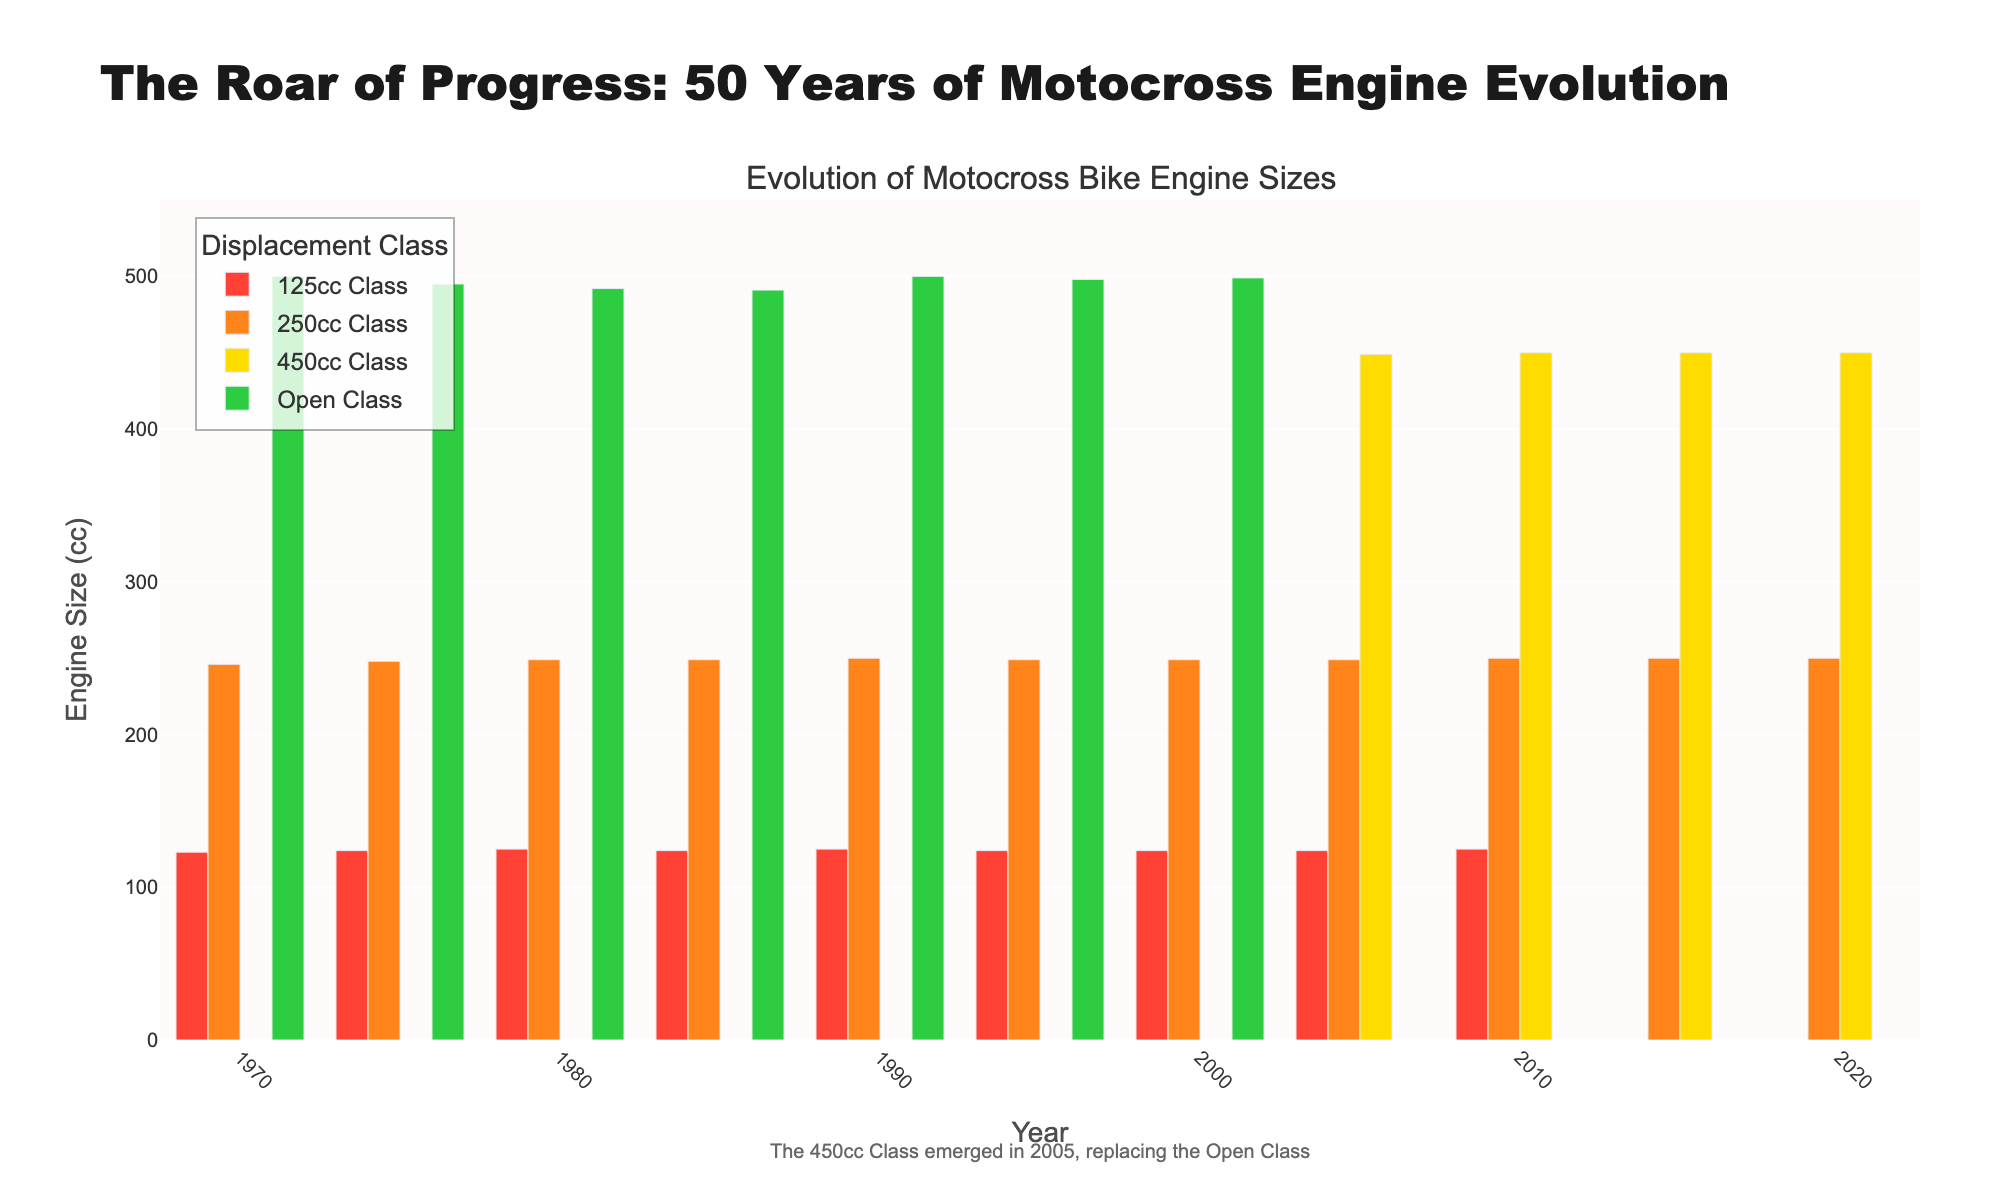Which class of motocross bikes was introduced in 2005? The figure contains annotations mentioning that the 450cc Class emerged in 2005, replacing the Open Class. From the bar heights in the figure, you can also notice the appearance of the bars for the 450cc Class starting from 2005.
Answer: 450cc Class Which year shows the highest bar for the 250cc Class? By examining the bar heights for the 250cc Class, you can see that the height remains consistent across all years, which means the highest bar is the same for all years available in the data.
Answer: All years (constant) What happened to the 125cc Class after 2010? After 2010, there are no visible bars for the 125cc Class, indicating that the data points for this class are marked as N/A in the subsequent years in the figure.
Answer: It disappeared What is the difference in the engine size between the 450cc Class and the Open Class in 2005? In 2005, the figure shows engine sizes of 449 cc for the 450cc Class and no data for the Open Class since it was replaced. Hence the apparent difference in engine sizes is 449 cc compared to N/A which can imply potential inconsistencies, but it's a visual gap to consider.
Answer: N/A Compare the engine sizes in 1980 for the 250cc Class and the Open Class. Comparing the heights of the bars for 1980, the 250cc Class has an engine size of 249 cc, and the Open Class has an engine size of 492 cc.
Answer: The Open Class is larger by 243 cc What is the arithmetic average of the engine sizes of the 125cc Class between 1970 and 2000? The engine sizes are: 1970: 123, 1975: 124, 1980: 125, 1985: 124, 1990: 125, 1995: 124, 2000: 124. The sum is 869, divided by 7 years gives an average of approximately 124.14 cc.
Answer: 124.14 cc Which year shows the highest engine size in the Open Class? By looking at the bar heights for the Open Class, the year 1970 shows the highest bar with an engine size of 500 cc.
Answer: 1970 Identify the visual trend of the 450cc Class from its introduction to 2020. The 450cc Class appears in 2005 and the bar heights remain constant at 450 cc through 2020, indicating no change in engine size over the years visually.
Answer: Constant at 450 cc 